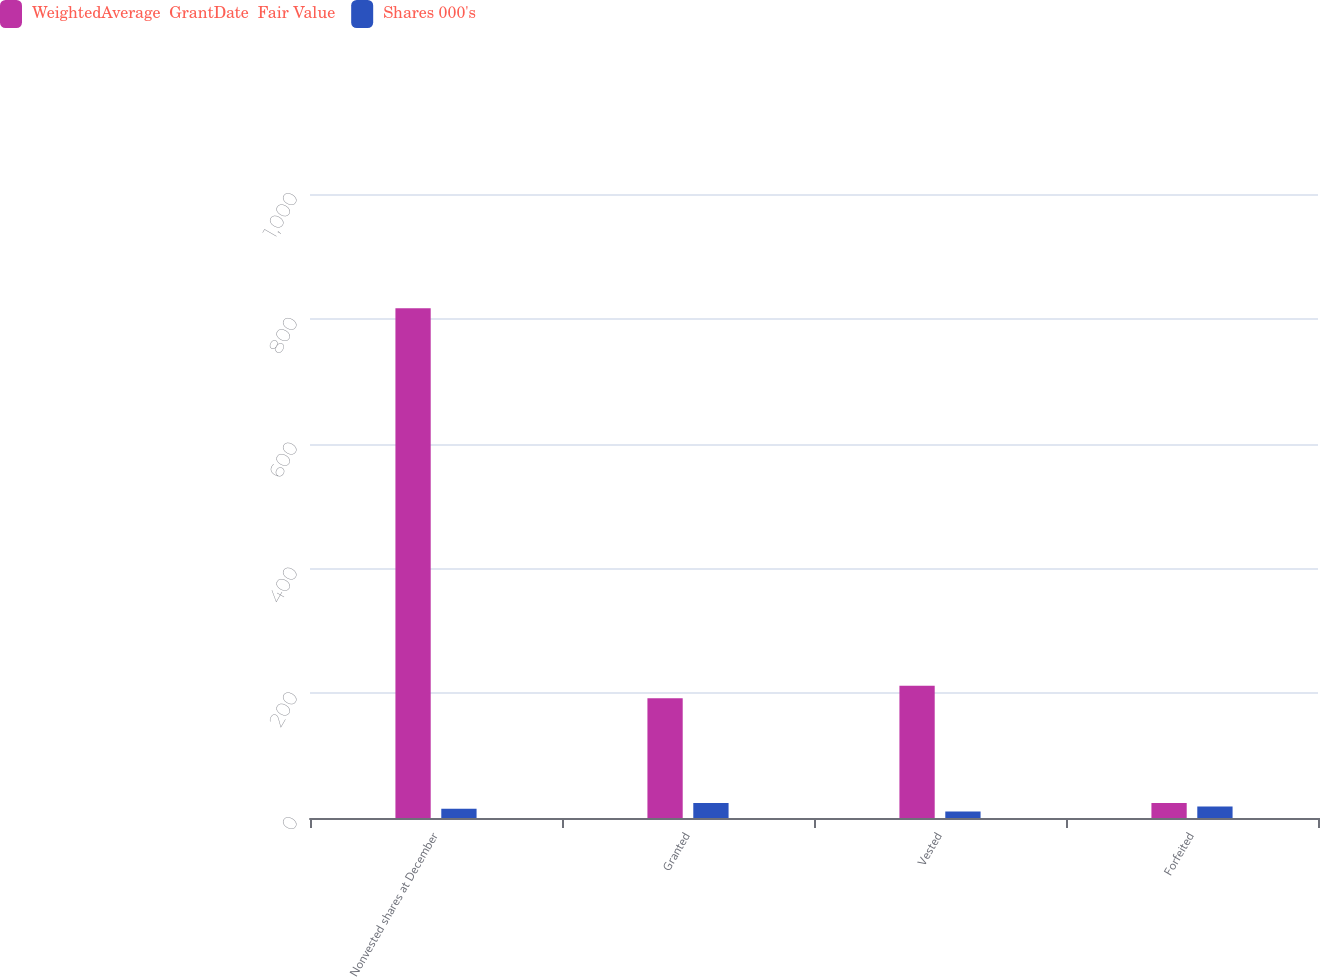Convert chart. <chart><loc_0><loc_0><loc_500><loc_500><stacked_bar_chart><ecel><fcel>Nonvested shares at December<fcel>Granted<fcel>Vested<fcel>Forfeited<nl><fcel>WeightedAverage  GrantDate  Fair Value<fcel>817<fcel>192<fcel>212<fcel>24<nl><fcel>Shares 000's<fcel>14.88<fcel>24.07<fcel>10.54<fcel>18.41<nl></chart> 